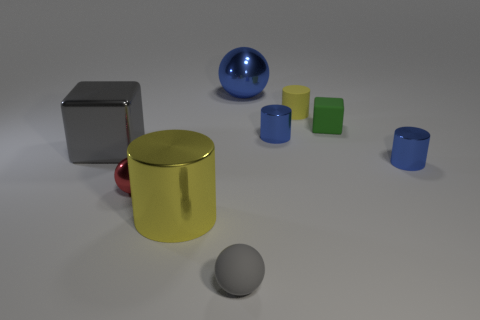There is a gray object that is the same shape as the green matte object; what is it made of? metal 